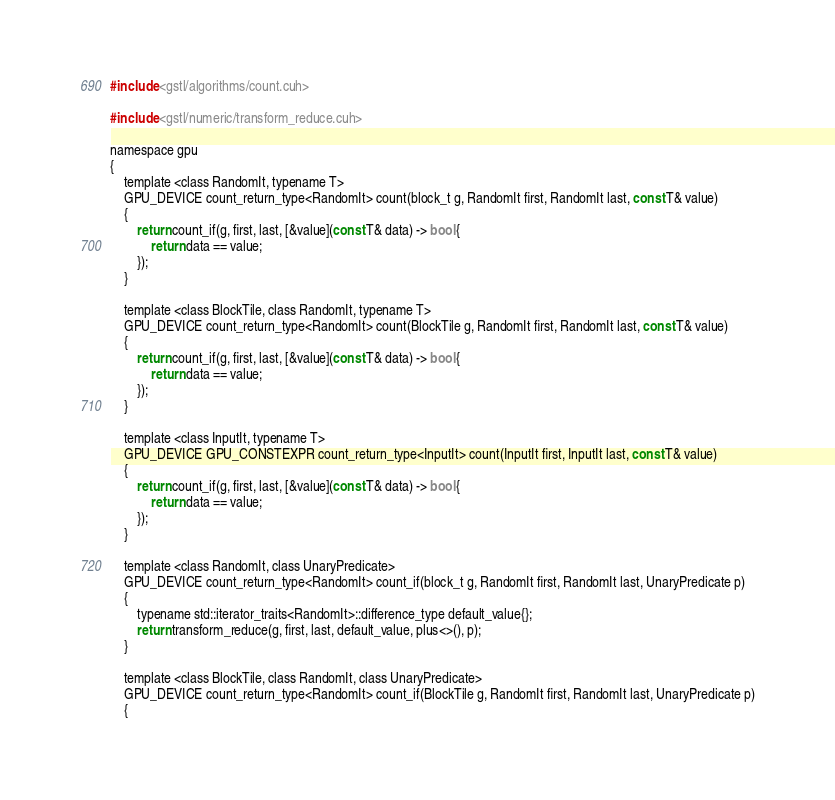<code> <loc_0><loc_0><loc_500><loc_500><_Cuda_>#include <gstl/algorithms/count.cuh>

#include <gstl/numeric/transform_reduce.cuh>

namespace gpu
{
	template <class RandomIt, typename T>
	GPU_DEVICE count_return_type<RandomIt> count(block_t g, RandomIt first, RandomIt last, const T& value)
	{
		return count_if(g, first, last, [&value](const T& data) -> bool {
			return data == value;
		});
	}

	template <class BlockTile, class RandomIt, typename T>
	GPU_DEVICE count_return_type<RandomIt> count(BlockTile g, RandomIt first, RandomIt last, const T& value)
	{
		return count_if(g, first, last, [&value](const T& data) -> bool {
			return data == value;
		});
	}

	template <class InputIt, typename T>
	GPU_DEVICE GPU_CONSTEXPR count_return_type<InputIt> count(InputIt first, InputIt last, const T& value)
	{
		return count_if(g, first, last, [&value](const T& data) -> bool {
			return data == value;
		});
	}

	template <class RandomIt, class UnaryPredicate>
	GPU_DEVICE count_return_type<RandomIt> count_if(block_t g, RandomIt first, RandomIt last, UnaryPredicate p)
	{
		typename std::iterator_traits<RandomIt>::difference_type default_value{};
		return transform_reduce(g, first, last, default_value, plus<>(), p);
	}

	template <class BlockTile, class RandomIt, class UnaryPredicate>
	GPU_DEVICE count_return_type<RandomIt> count_if(BlockTile g, RandomIt first, RandomIt last, UnaryPredicate p)
	{</code> 